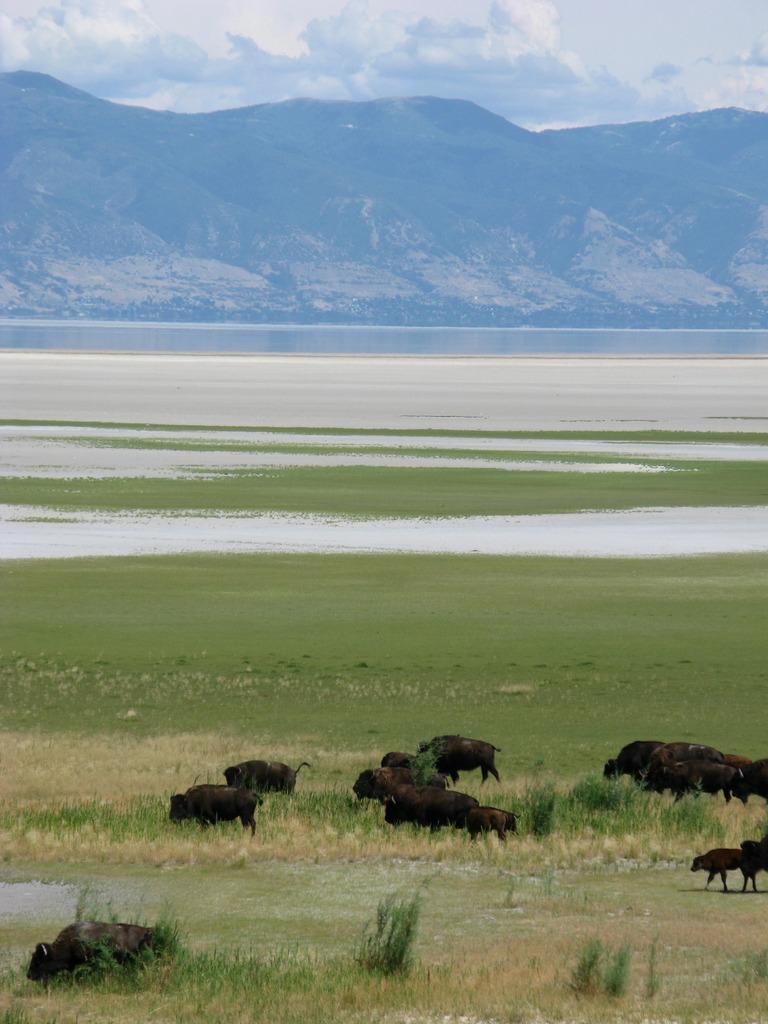Describe this image in one or two sentences. In front of the image there are buffaloes. At the bottom of the image there is grass on the surface. In the background of the image there is water. There are mountains. At the top of the image there are clouds in the sky. 